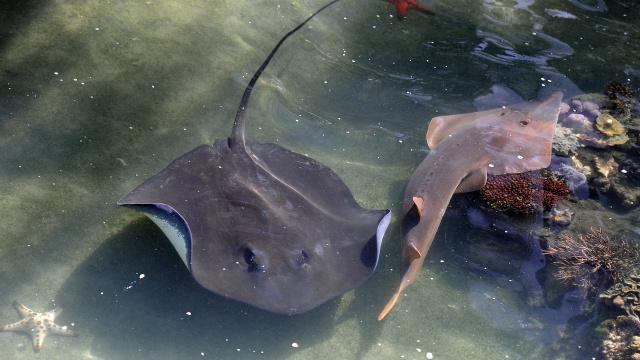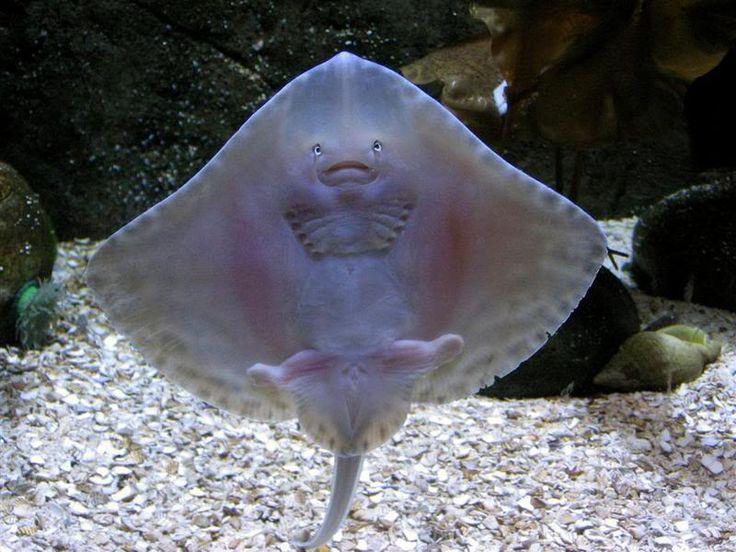The first image is the image on the left, the second image is the image on the right. For the images displayed, is the sentence "One stingray with its underside facing the camera is in the foreground of an image." factually correct? Answer yes or no. Yes. The first image is the image on the left, the second image is the image on the right. Examine the images to the left and right. Is the description "The underside of one of the rays in the water is visible in one of the images." accurate? Answer yes or no. Yes. 